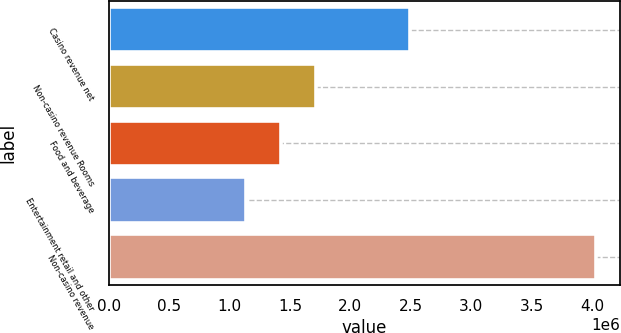<chart> <loc_0><loc_0><loc_500><loc_500><bar_chart><fcel>Casino revenue net<fcel>Non-casino revenue Rooms<fcel>Food and beverage<fcel>Entertainment retail and other<fcel>Non-casino revenue<nl><fcel>2.49247e+06<fcel>1.71682e+06<fcel>1.42798e+06<fcel>1.13914e+06<fcel>4.02754e+06<nl></chart> 